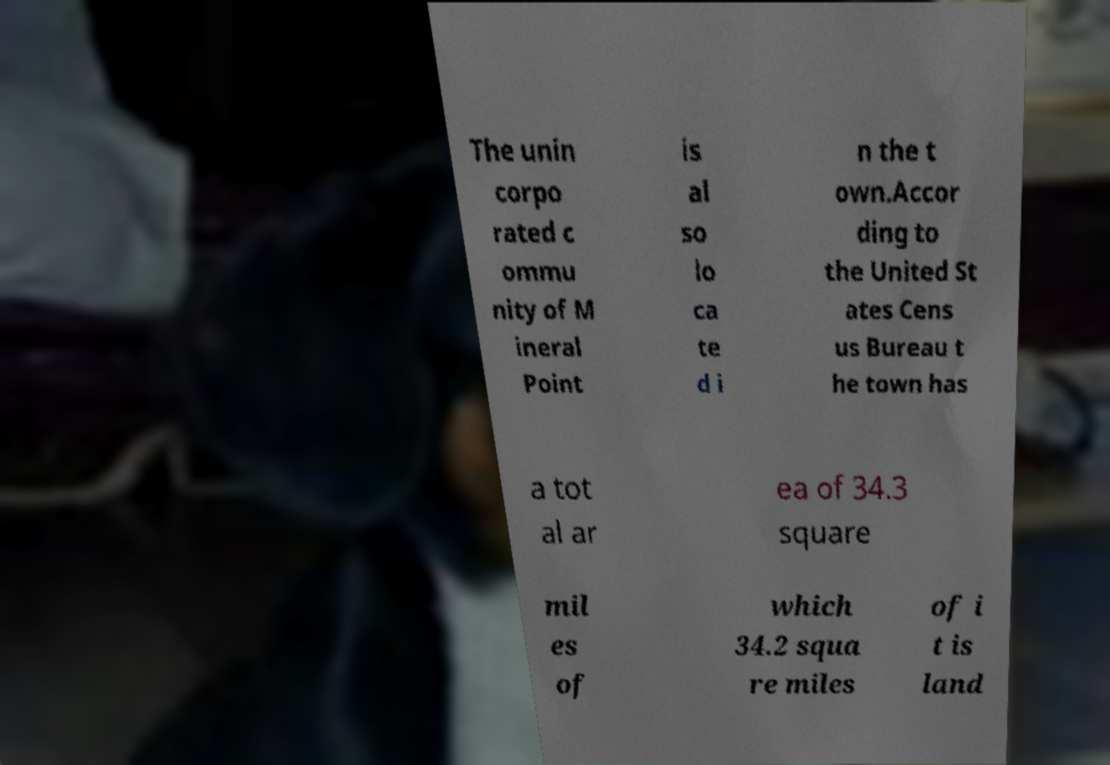There's text embedded in this image that I need extracted. Can you transcribe it verbatim? The unin corpo rated c ommu nity of M ineral Point is al so lo ca te d i n the t own.Accor ding to the United St ates Cens us Bureau t he town has a tot al ar ea of 34.3 square mil es of which 34.2 squa re miles of i t is land 